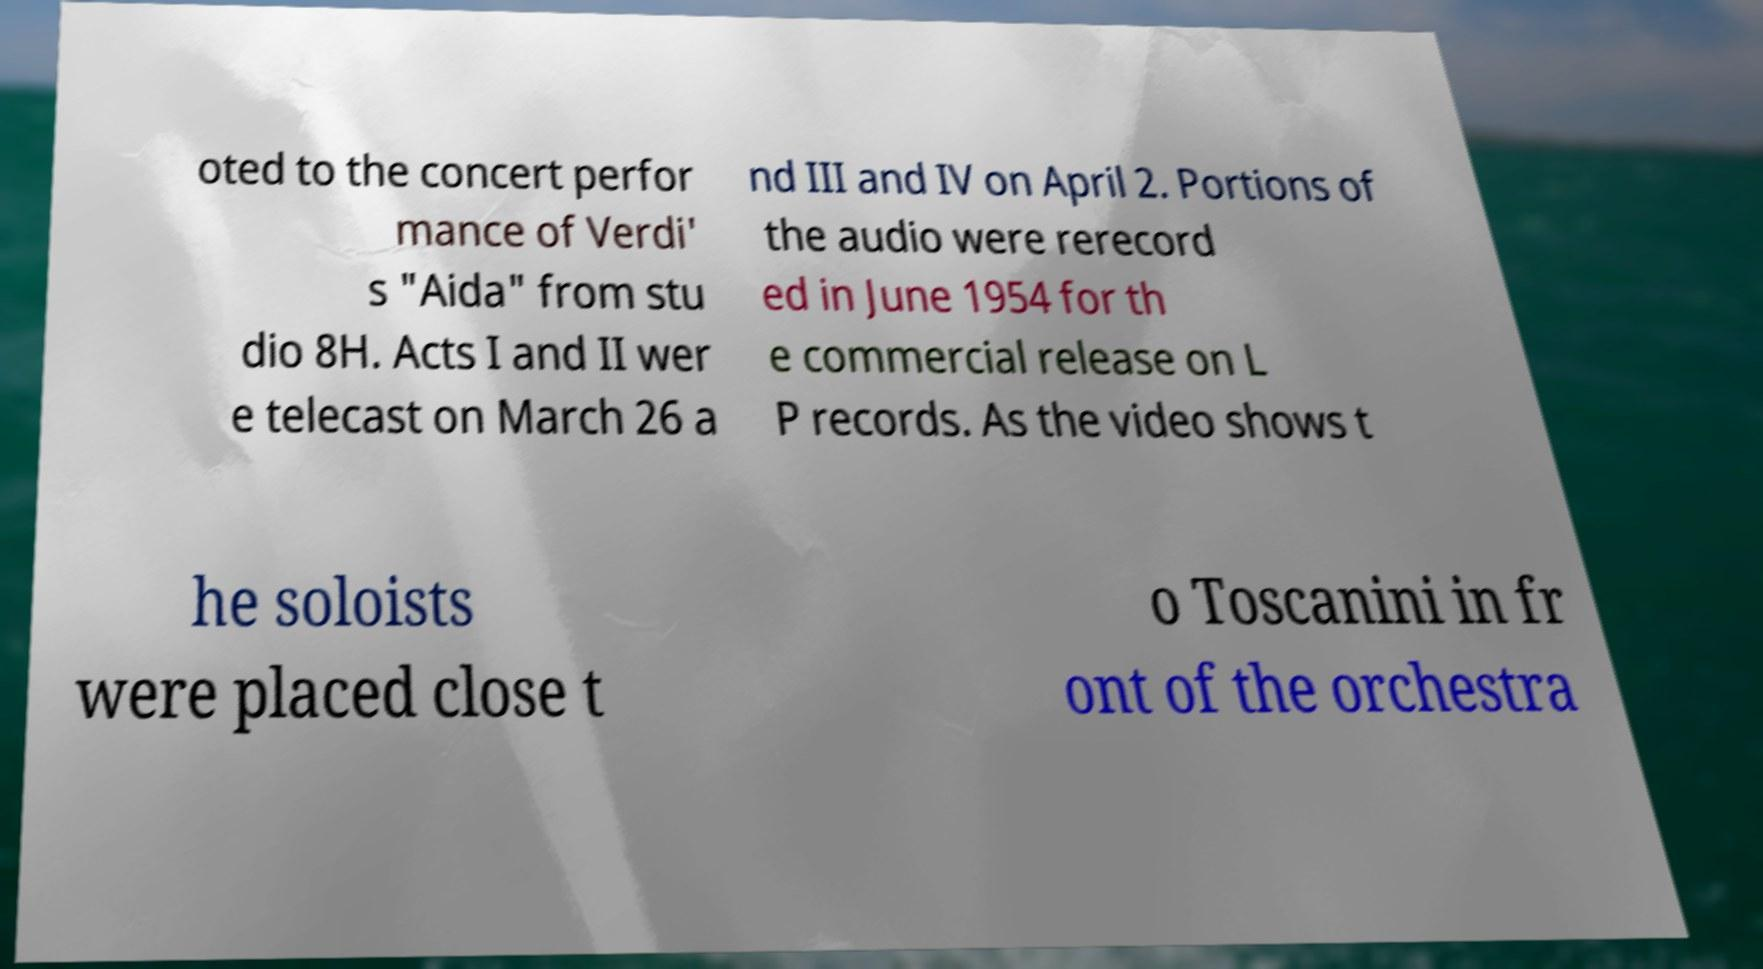What messages or text are displayed in this image? I need them in a readable, typed format. oted to the concert perfor mance of Verdi' s "Aida" from stu dio 8H. Acts I and II wer e telecast on March 26 a nd III and IV on April 2. Portions of the audio were rerecord ed in June 1954 for th e commercial release on L P records. As the video shows t he soloists were placed close t o Toscanini in fr ont of the orchestra 